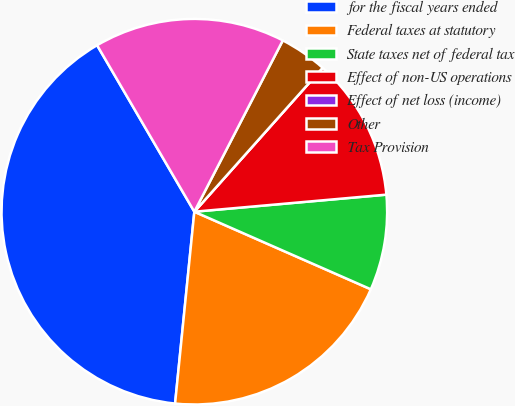Convert chart. <chart><loc_0><loc_0><loc_500><loc_500><pie_chart><fcel>for the fiscal years ended<fcel>Federal taxes at statutory<fcel>State taxes net of federal tax<fcel>Effect of non-US operations<fcel>Effect of net loss (income)<fcel>Other<fcel>Tax Provision<nl><fcel>39.99%<fcel>20.0%<fcel>8.0%<fcel>12.0%<fcel>0.0%<fcel>4.0%<fcel>16.0%<nl></chart> 